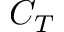Convert formula to latex. <formula><loc_0><loc_0><loc_500><loc_500>C _ { T }</formula> 